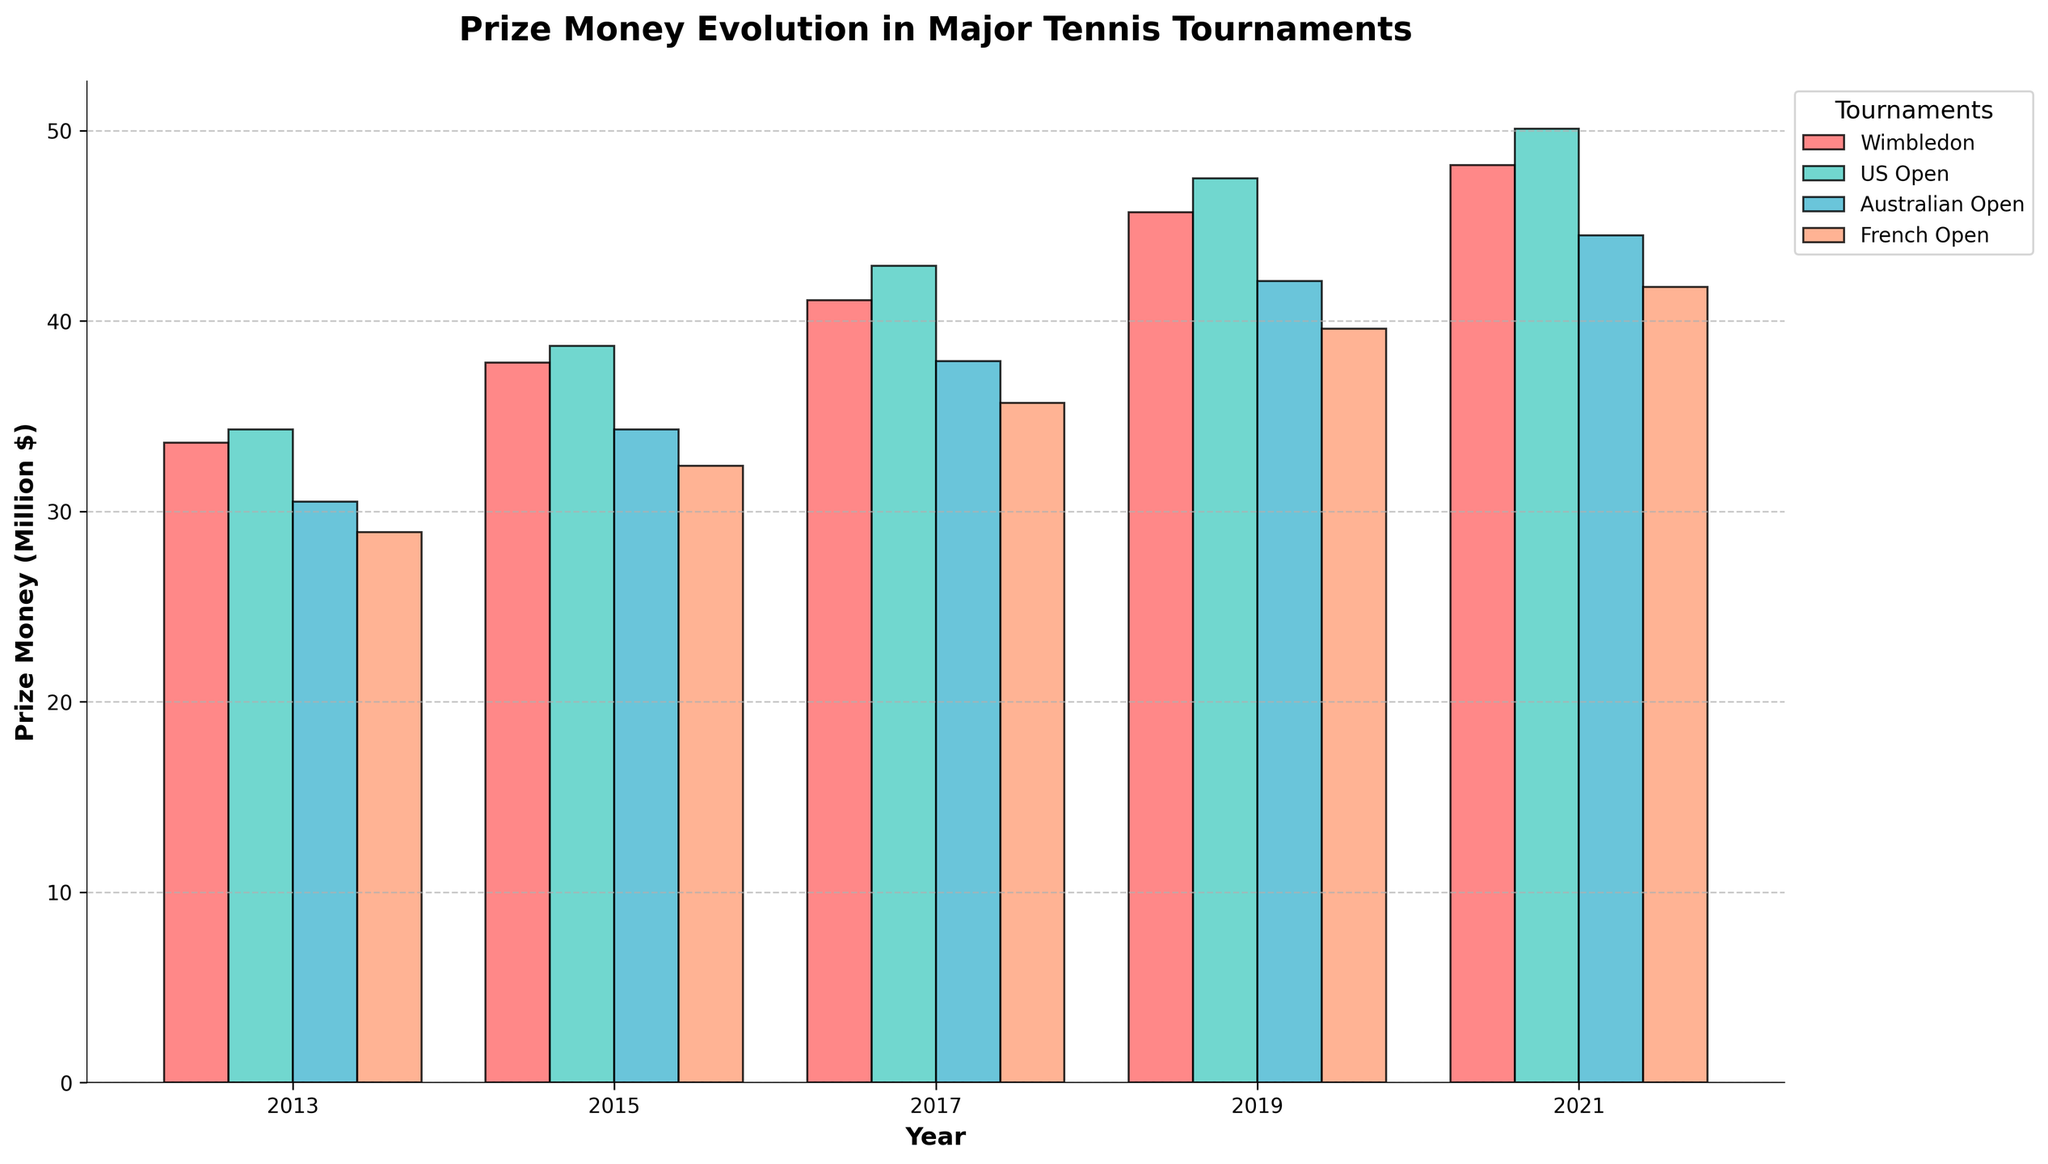What is the trend in prize money for Wimbledon over the years 2013 to 2021? To determine the trend in prize money for Wimbledon, observe the heights of the bars corresponding to the years 2013, 2015, 2017, 2019, and 2021 in the section labeled "Wimbledon". Notice that the bars generally increase in height over the years.
Answer: Increasing Which tournament had the highest prize money in 2021? Look at the bars for the year 2021 and compare their heights. The tournament with the tallest bar represents the highest prize money.
Answer: US Open Is the prize money for the US Open in 2017 greater than the prize money for the French Open in 2019? Compare the height of the bar for the US Open in 2017 with the bar for the French Open in 2019.
Answer: Yes What is the difference in prize money between Wimbledon and the Australian Open in 2015? Find the bars for Wimbledon and the Australian Open in 2015 and measure their heights. Subtract the height of the Australian Open bar from the height of the Wimbledon bar to find the difference.
Answer: 3.5 million $ Which tournament's prize money increased the most from 2013 to 2021? Calculate the difference in bar heights from 2013 to 2021 for each tournament. The tournament with the largest difference has the greatest increase in prize money.
Answer: Wimbledon How much did the prize money for the French Open increase from 2013 to 2017? Find the heights of the bars for the French Open in 2013 and 2017, and subtract the 2013 value from the 2017 value.
Answer: 6.8 million $ In which year did the Australian Open first surpass 40 million dollars in prize money? Locate the bar heights for the Australian Open and identify the first year when the height exceeds 40 million dollars.
Answer: 2019 